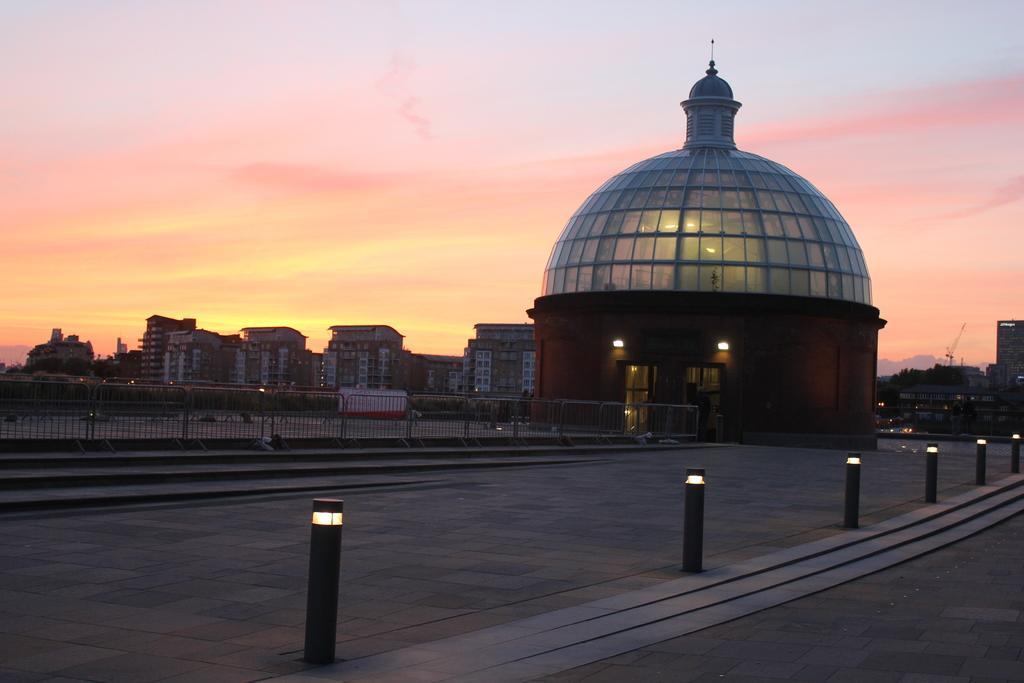Please provide a concise description of this image. There are lights attached to the small poles, which are on the road. In the background, there is a fence, there are buildings and there are clouds in the sky. 